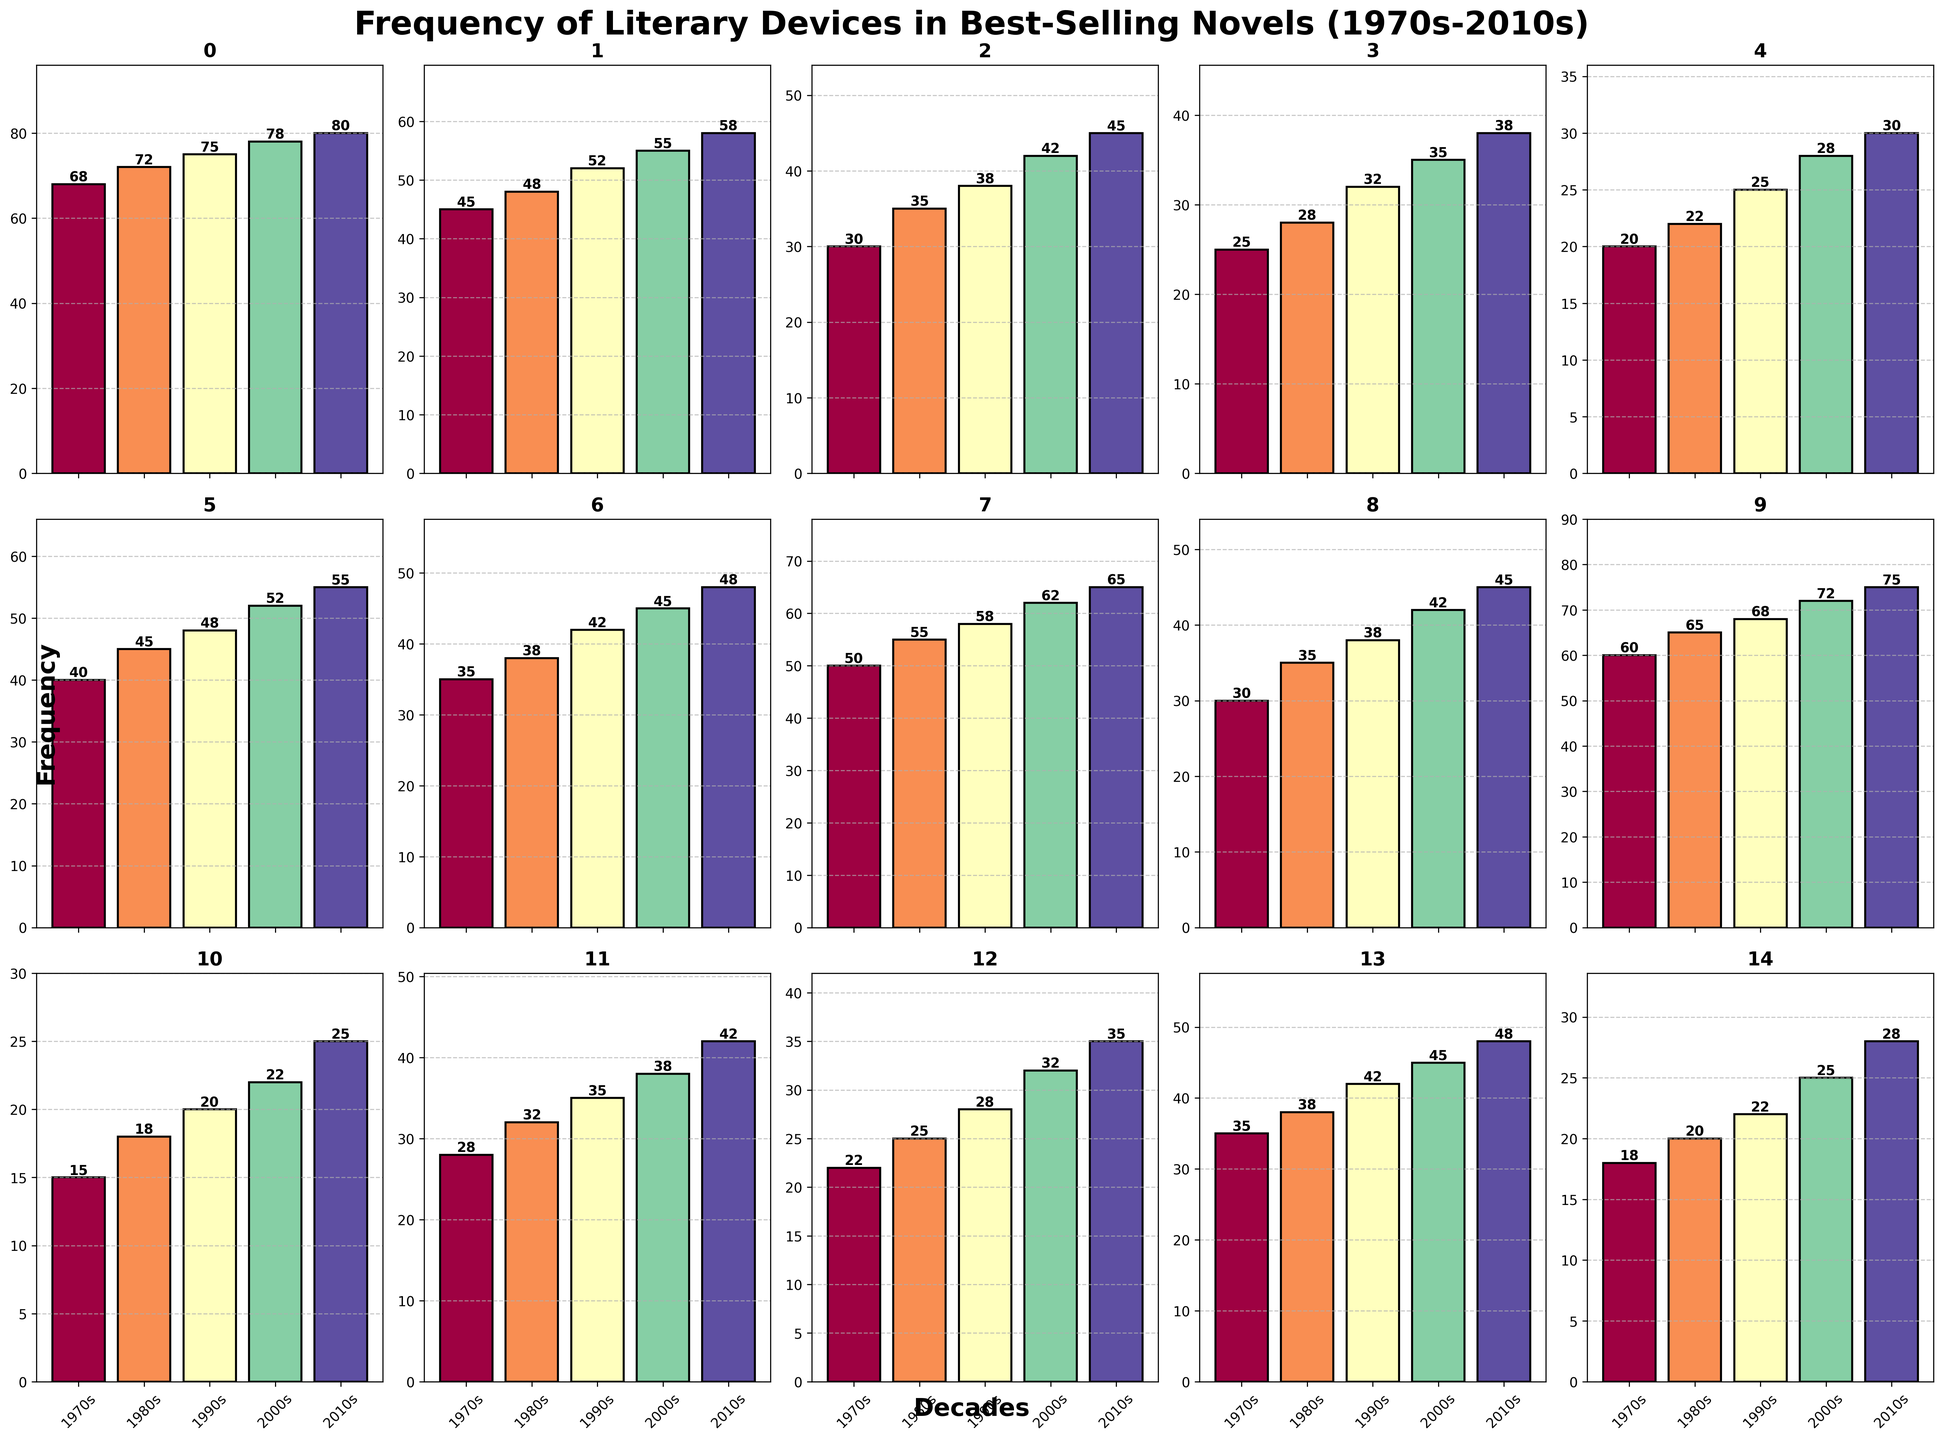what is the most frequently used literary device in the 2010s? Examine the heights of the bars labeled "2010s" and find the one that is the tallest. In this case, the "Metaphor" bar is the tallest for the 2010s.
Answer: Metaphor Which literary device had the least increase in usage from the 1970s to the 2010s? Calculate the differences in heights of the bars for each device from the 1970s to the 2010s. Among them, "Onomatopoeia" has the smallest increase (25 - 15 = 10).
Answer: Onomatopoeia Compare the usage of "Irony" and "Personification" in the 2000s. Which one was used more? Look at the bars for "Irony" and "Personification" in the 2000s. The height of the "Irony" bar is 52 and the height of the "Personification" bar is 42. Therefore, "Irony" was used more.
Answer: Irony What is the total frequency of "Imagery" and "Symbolism" in the 1980s? Add the heights of the bars for "Imagery" and "Symbolism" in the 1980s. "Imagery" is 65 and "Symbolism" is 55. So the total is 65 + 55 = 120.
Answer: 120 Which decade saw the largest increase in "Hyperbole" usage compared to the previous decade? Calculate the changes in heights between decades for "Hyperbole". The largest change is between the 1990s and 2000s (28 - 25 = 3).
Answer: 2000s How many literary devices had a frequency of 45 or more in the 2010s? Count the number of bars in the 2010s that have heights of 45 or more. These include "Metaphor", "Simile", "Personification", "Irony", "Symbolism", "Imagery", "Flashback", "Repetition". So the count is 8.
Answer: 8 